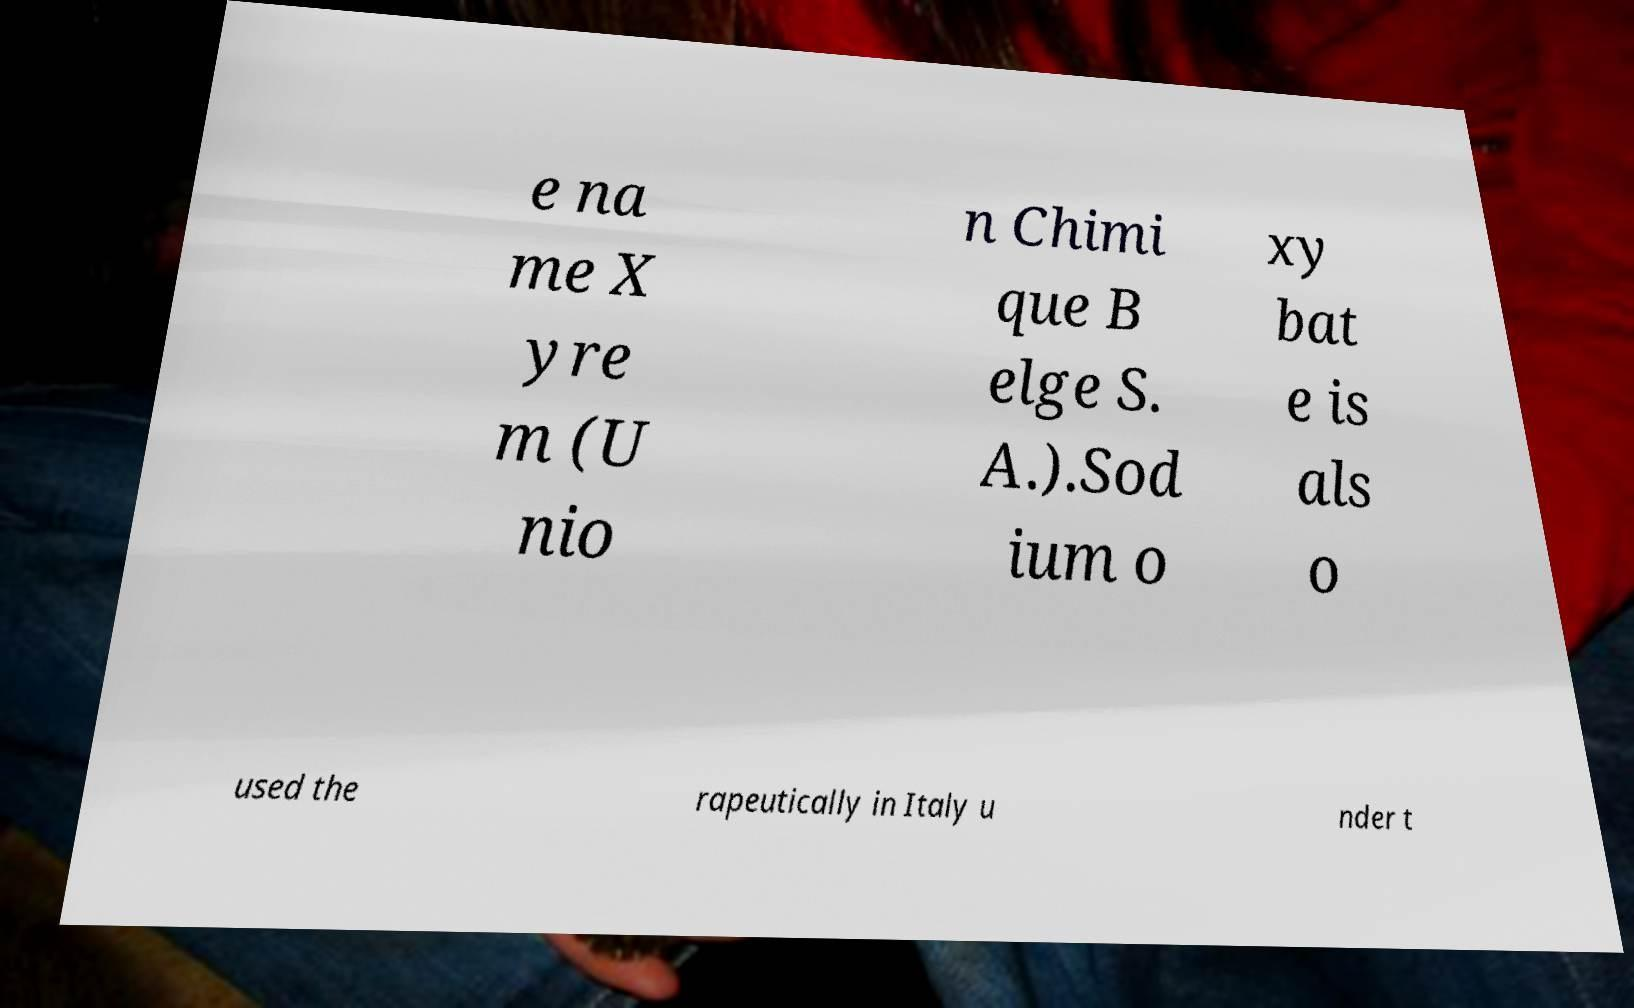I need the written content from this picture converted into text. Can you do that? e na me X yre m (U nio n Chimi que B elge S. A.).Sod ium o xy bat e is als o used the rapeutically in Italy u nder t 